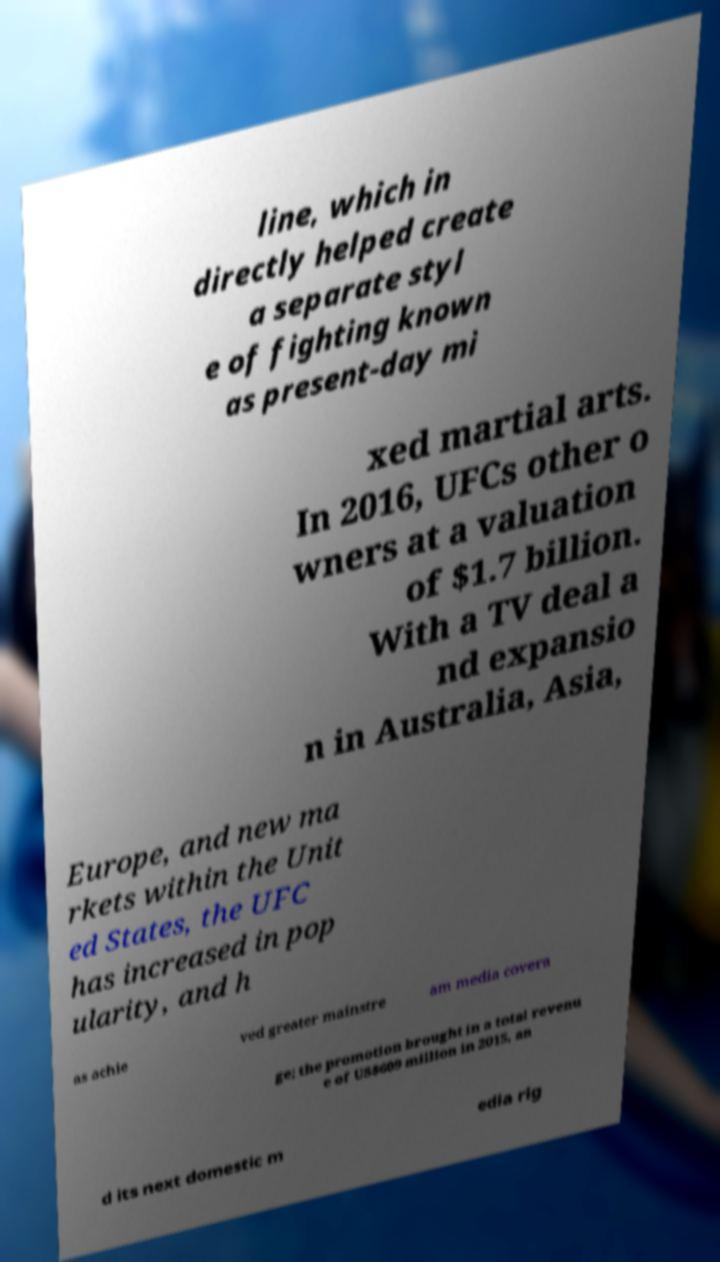Could you assist in decoding the text presented in this image and type it out clearly? line, which in directly helped create a separate styl e of fighting known as present-day mi xed martial arts. In 2016, UFCs other o wners at a valuation of $1.7 billion. With a TV deal a nd expansio n in Australia, Asia, Europe, and new ma rkets within the Unit ed States, the UFC has increased in pop ularity, and h as achie ved greater mainstre am media covera ge; the promotion brought in a total revenu e of US$609 million in 2015, an d its next domestic m edia rig 